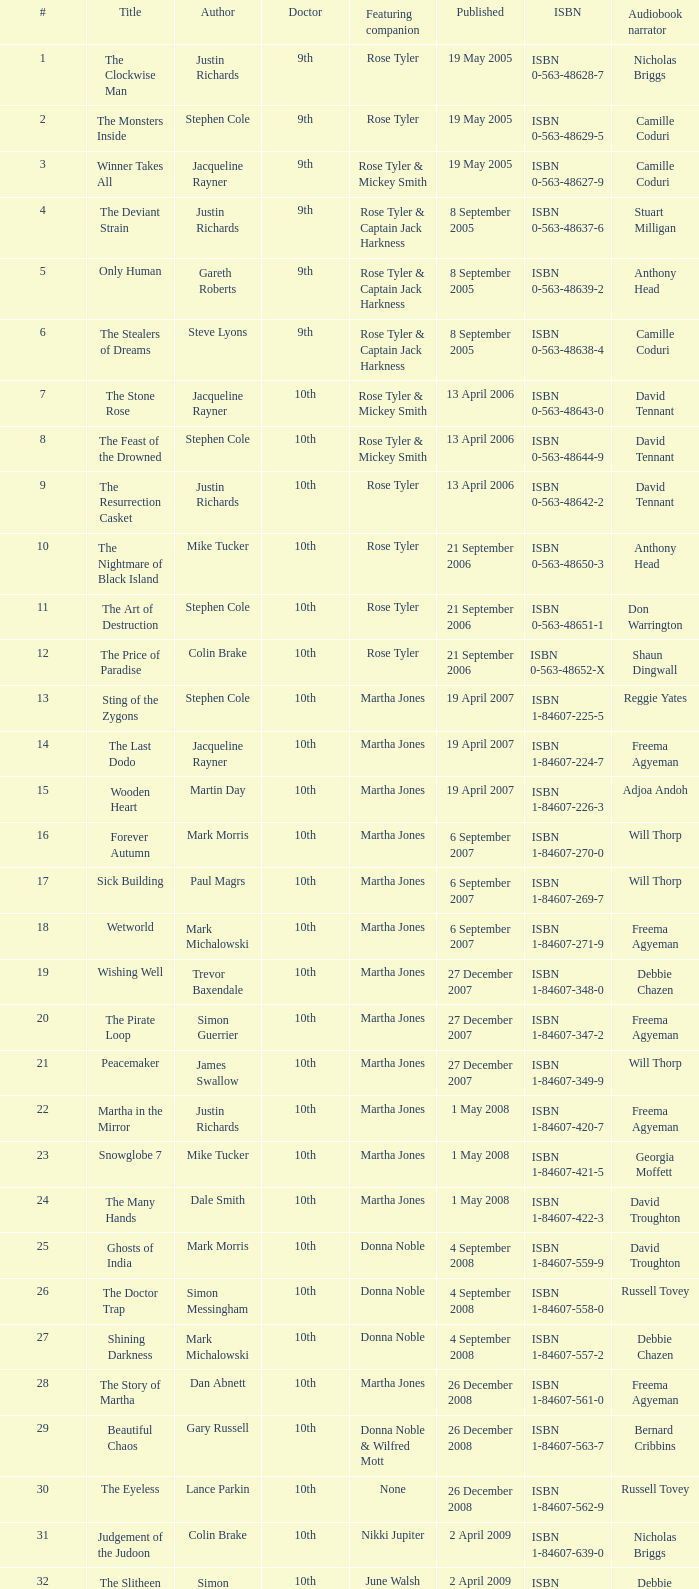What is the title of book number 7? The Stone Rose. 